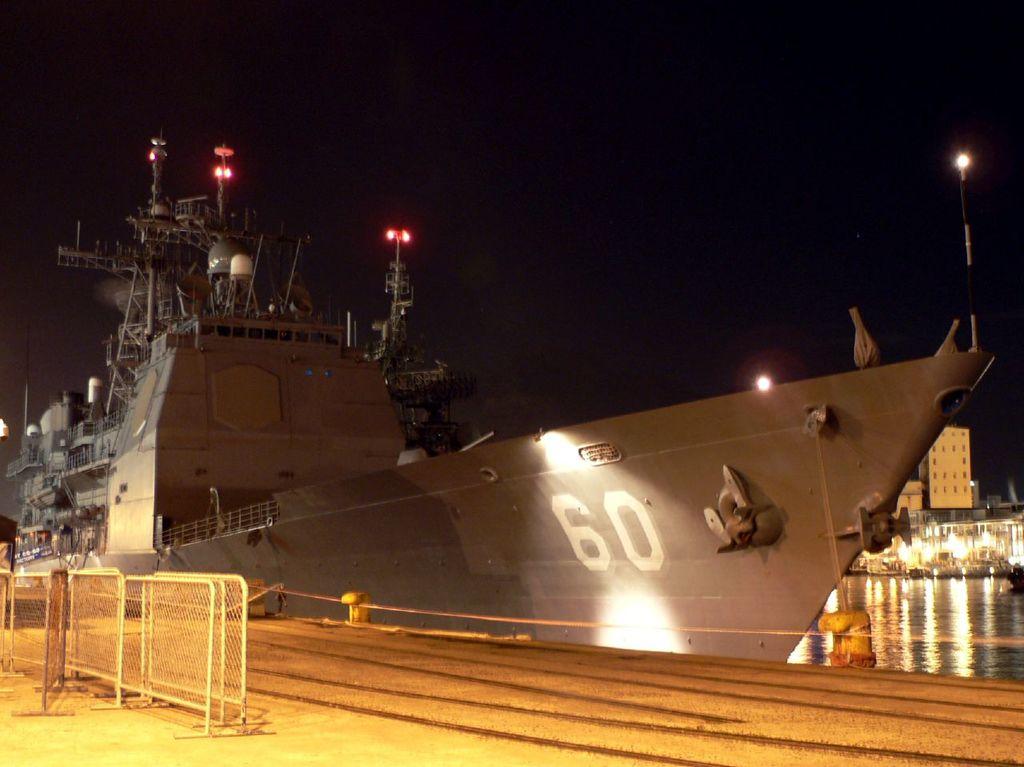What number is painted on the hull of the ship?
Your response must be concise. 60. 